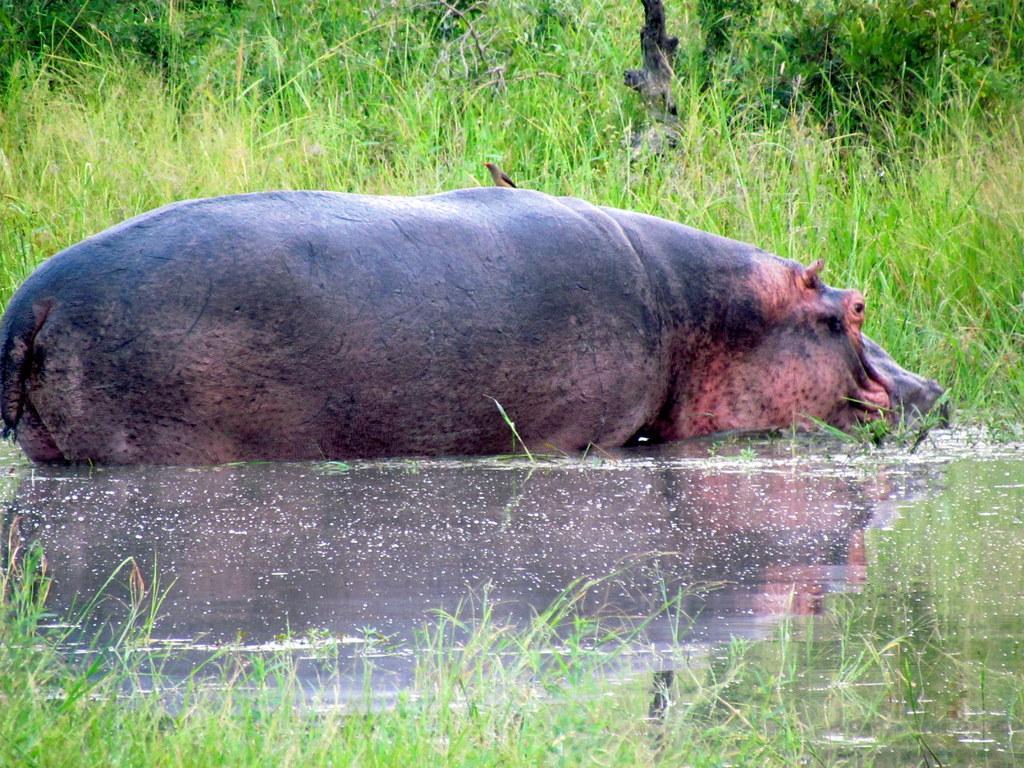Can you describe this image briefly? In this image, I can see a bird on a hippopotamus, which is in the water. I can see the grass and a branch. 